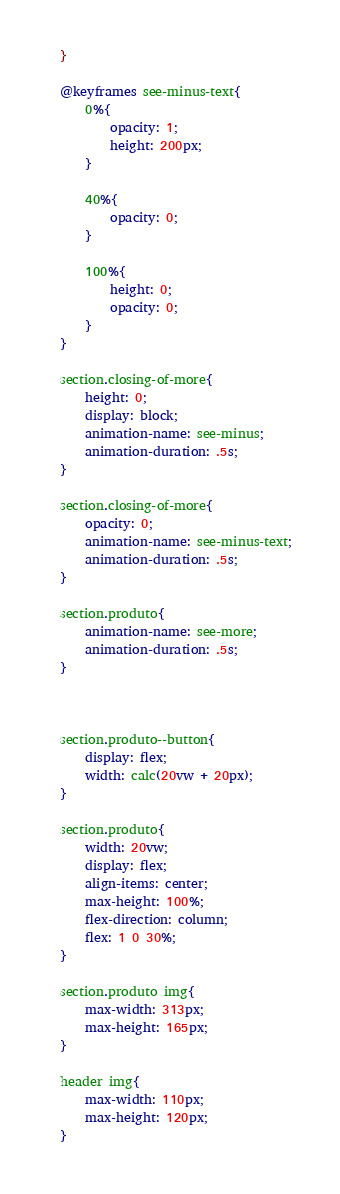Convert code to text. <code><loc_0><loc_0><loc_500><loc_500><_CSS_>}

@keyframes see-minus-text{
    0%{
        opacity: 1;
        height: 200px;
    }

    40%{
        opacity: 0;
    }

    100%{
        height: 0;
        opacity: 0;
    }
}

section.closing-of-more{
    height: 0;
    display: block;
    animation-name: see-minus;
    animation-duration: .5s;
}

section.closing-of-more{
    opacity: 0;
    animation-name: see-minus-text;
    animation-duration: .5s;
}

section.produto{
    animation-name: see-more;
    animation-duration: .5s;
}



section.produto--button{
    display: flex;
    width: calc(20vw + 20px);
}

section.produto{
    width: 20vw;
    display: flex;
    align-items: center;
    max-height: 100%;
    flex-direction: column;
    flex: 1 0 30%;
}

section.produto img{
    max-width: 313px;
    max-height: 165px;
}

header img{
    max-width: 110px;
    max-height: 120px;
}</code> 